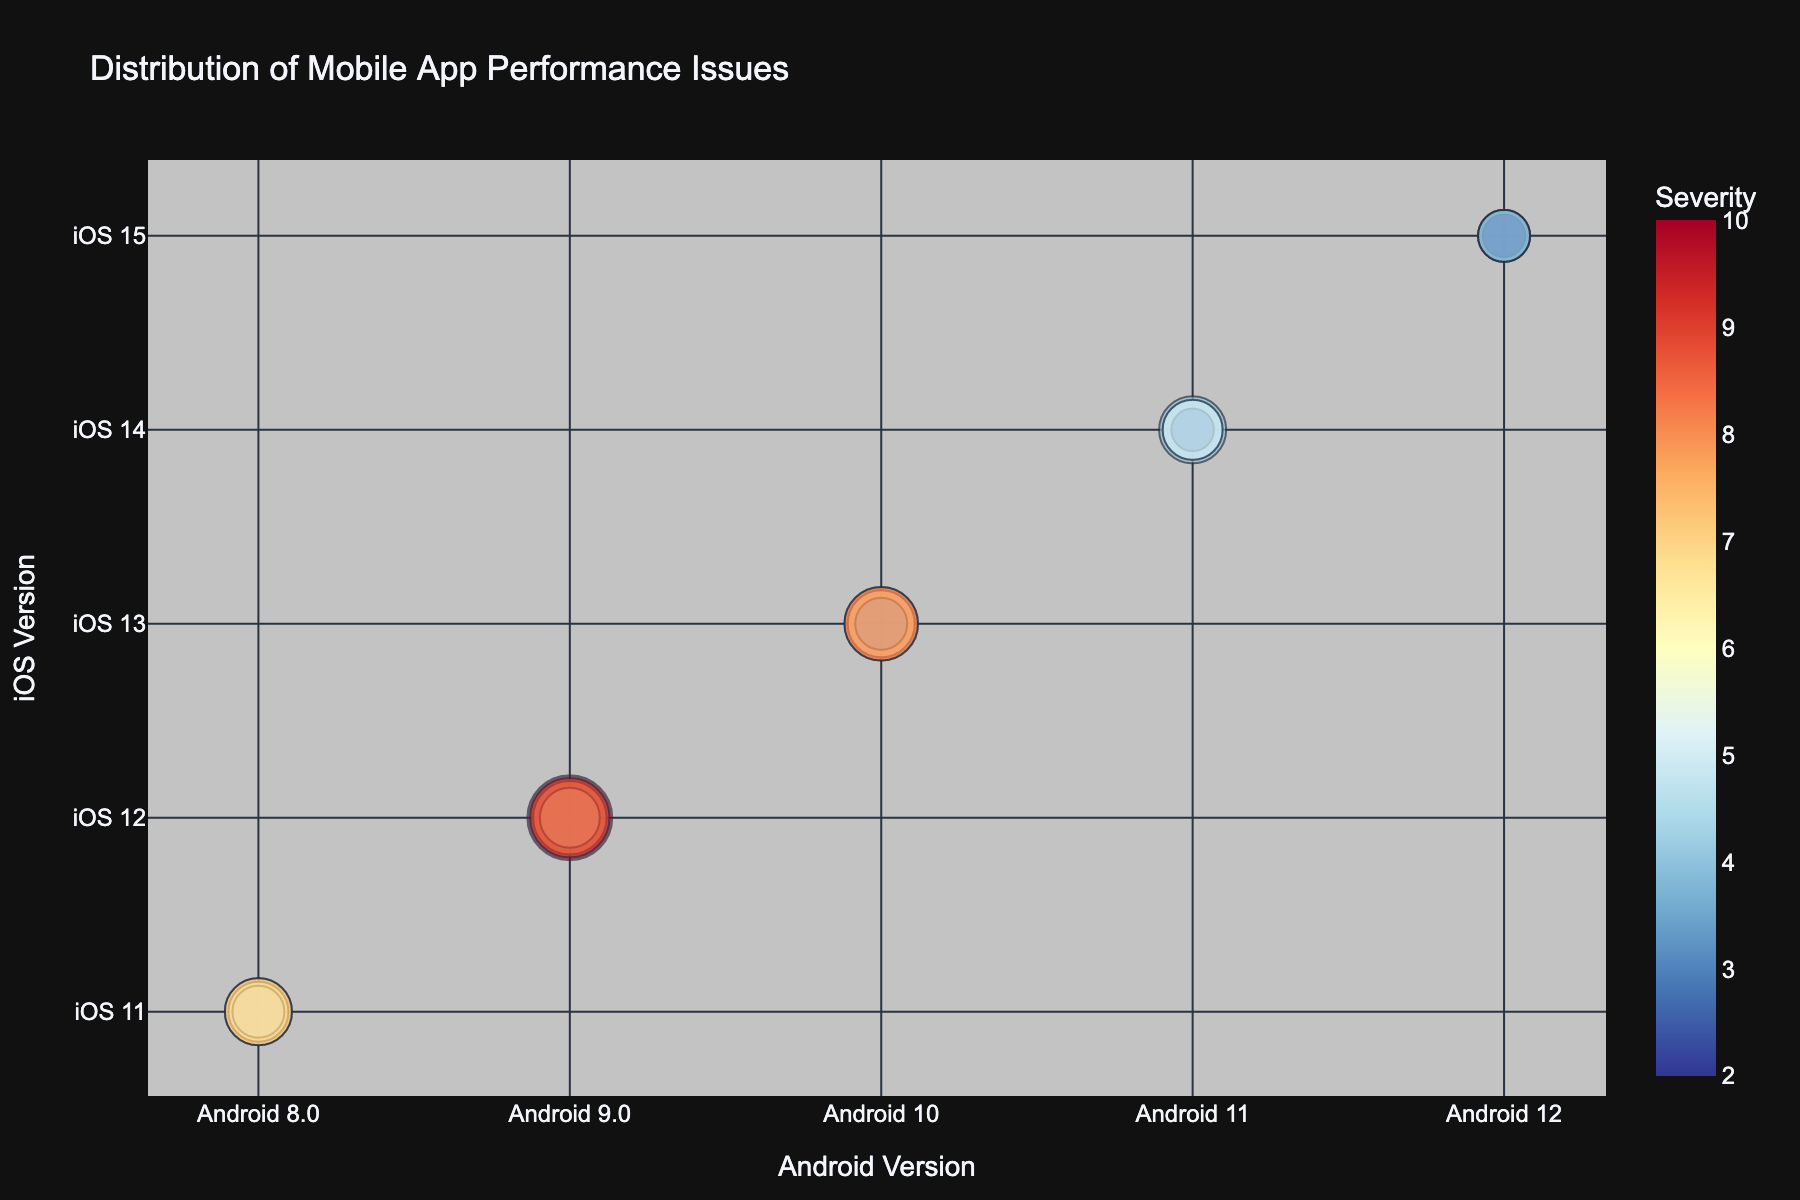What is the title of the chart? The title of the chart is usually displayed at the top and summarizes the content. In this chart, it's easy to locate the title.
Answer: Distribution of Mobile App Performance Issues How many different Android versions are compared in the chart? Count the unique labels on the x-axis to determine the number of different Android versions included in the chart.
Answer: 5 Which app issue type has the highest occurrence rate for Android 9.0 and iOS 12? By examining the size of the bubbles overlapping at Android 9.0 and iOS 12, the largest bubble indicates the highest occurrence rate.
Answer: Crashes What is the frequency of battery drain issues for Android 12 and iOS 15? Identify the size of the bubble located at Android 12 and iOS 15 for battery drain issues; hover over the bubble to see the precise value.
Answer: 3 Which mobile app performance issue has the lowest impact score and what are the corresponding Android and iOS versions? By observing the color of the bubbles, the bubble with the least intense shade represents the lowest impact score. Hover over the bubble for impact score and respective Android and iOS versions.
Answer: UI Lags, Android 12, iOS 15 Among crashes and slow responses for Android 10 and iOS 13, which has the higher impact score? Compare the color intensity of the bubbles for crashes and slow responses at the specified versions, where a darker shade indicates a higher impact score.
Answer: Crashes Compare the occurrence rates of UI lags between Android 8.0/iOS 11 and Android 11/iOS 14. Which version has a higher rate? Check the size of the bubbles at Android 8.0/iOS 11 and Android 11/iOS 14 for UI lags. The larger bubble corresponds to a higher occurrence rate.
Answer: Android 8.0/iOS 11 What is the severity level for crashes in Android 11 and iOS 14? Hover over the bubble corresponding to crashes at Android 11 and iOS 14 to see the severity level.
Answer: Medium 